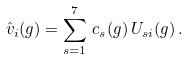Convert formula to latex. <formula><loc_0><loc_0><loc_500><loc_500>\hat { v } _ { i } ( g ) = \sum _ { s = 1 } ^ { 7 } \, c _ { s } ( g ) \, U _ { s i } ( g ) \, .</formula> 